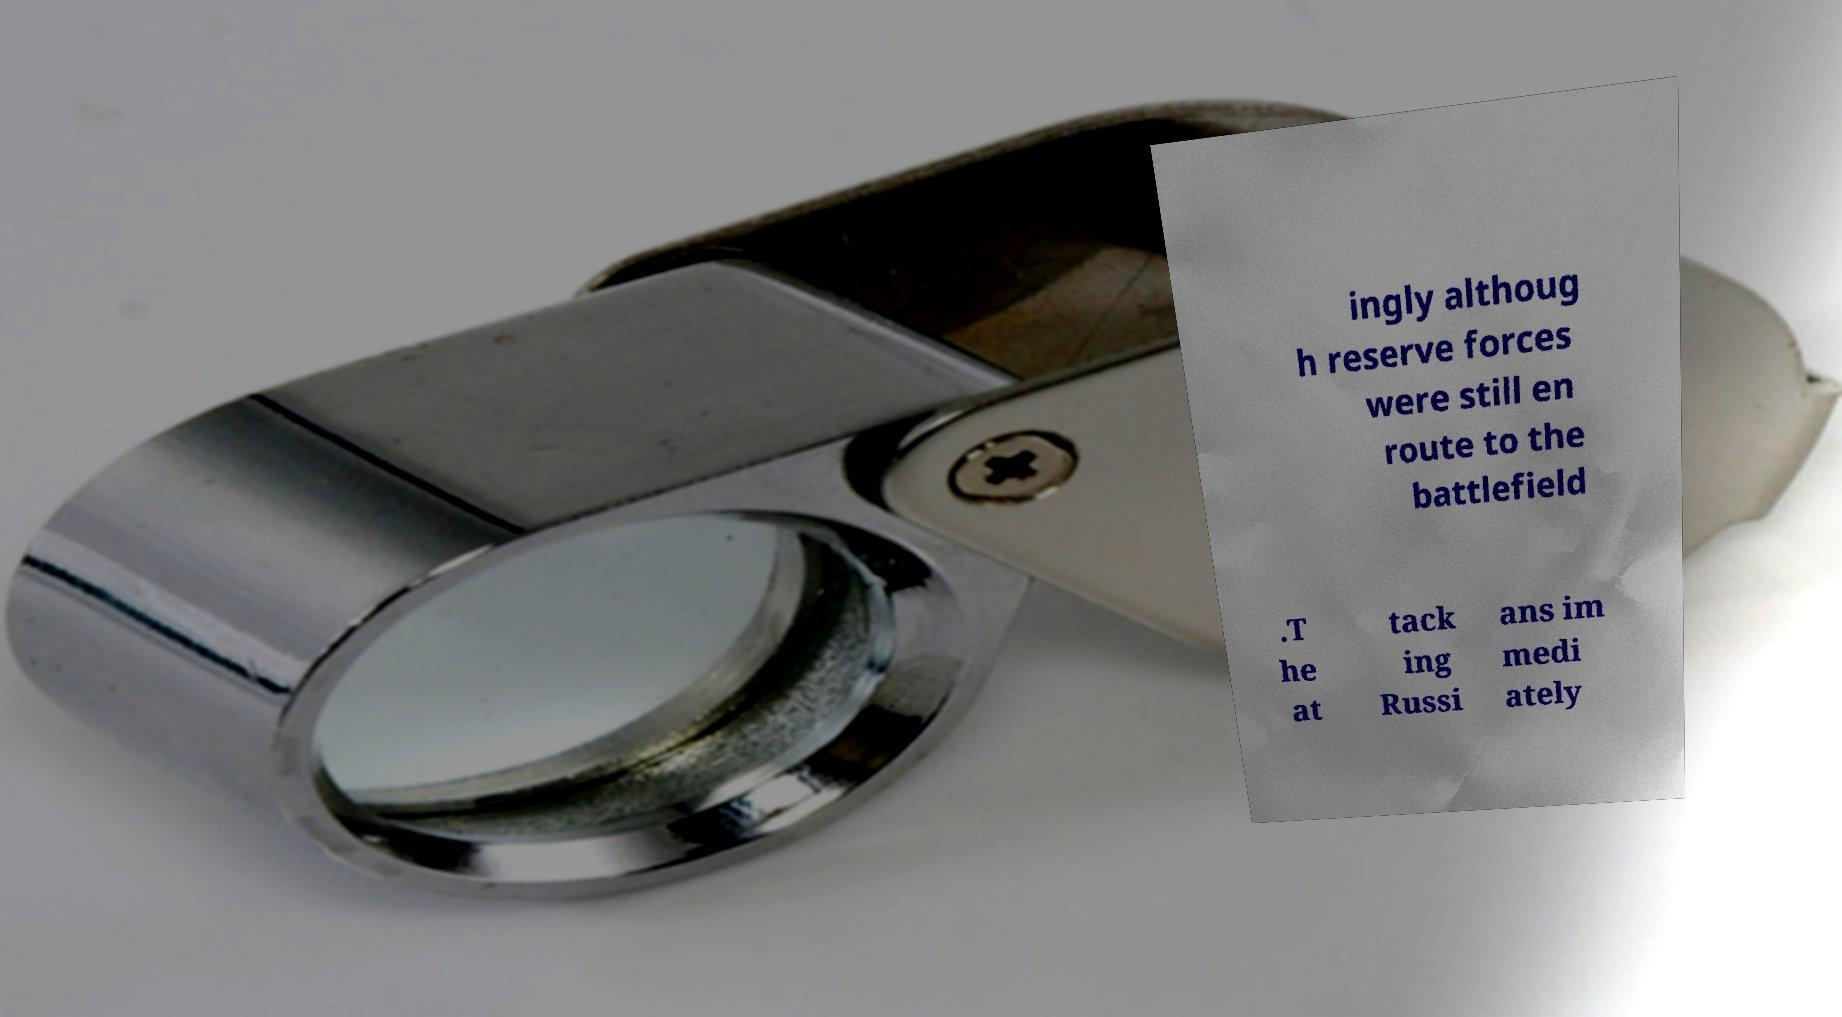I need the written content from this picture converted into text. Can you do that? ingly althoug h reserve forces were still en route to the battlefield .T he at tack ing Russi ans im medi ately 